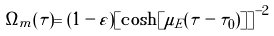Convert formula to latex. <formula><loc_0><loc_0><loc_500><loc_500>\Omega _ { m } ( \tau ) = ( 1 - \varepsilon ) \left [ \cosh [ \mu _ { E } ( \tau - \tau _ { 0 } ) ] \right ] ^ { - 2 }</formula> 